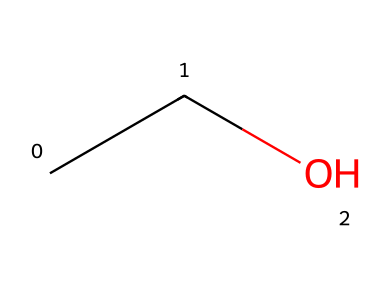What is the name of this chemical? The chemical structure represented by the SMILES 'CCO' is known as ethanol, which is a primary alcohol.
Answer: ethanol How many carbon atoms are in this molecule? The SMILES 'CCO' indicates two 'C' (carbon) symbols, so there are two carbon atoms in this molecule.
Answer: 2 What type of bond connects the carbon and oxygen in this chemical? In the 'CCO' structure, the carbon (C) is bonded to the oxygen (O) through a single bond (notated implicitly by the absence of other indicators in the SMILES).
Answer: single bond What is the molecular formula of this chemical? The number of carbon (C), hydrogen (H), and oxygen (O) atoms in 'CCO' can be counted: 2 C, 6 H (since each carbon is attached to three hydrogens), and 1 O. This combines to form C2H6O.
Answer: C2H6O Does this chemical have an alcohol functional group? The presence of the '-OH' group (represented in the 'CCO' by the O at the end) indicates it has an alcohol functional group, as alcohols are characterized by this group.
Answer: yes How does the number of carbon atoms affect the boiling point of this alcohol? Generally, as the number of carbon atoms increases in alcohols, the boiling point increases due to increased van der Waals forces. Ethanol, with 2 carbons, has a relatively low boiling point compared to larger alcohols.
Answer: increases What is the primary use of this chemical in wines? Ethanol is primarily used as the alcohol component in wines, contributing to flavor and effects when consumed.
Answer: alcohol component 